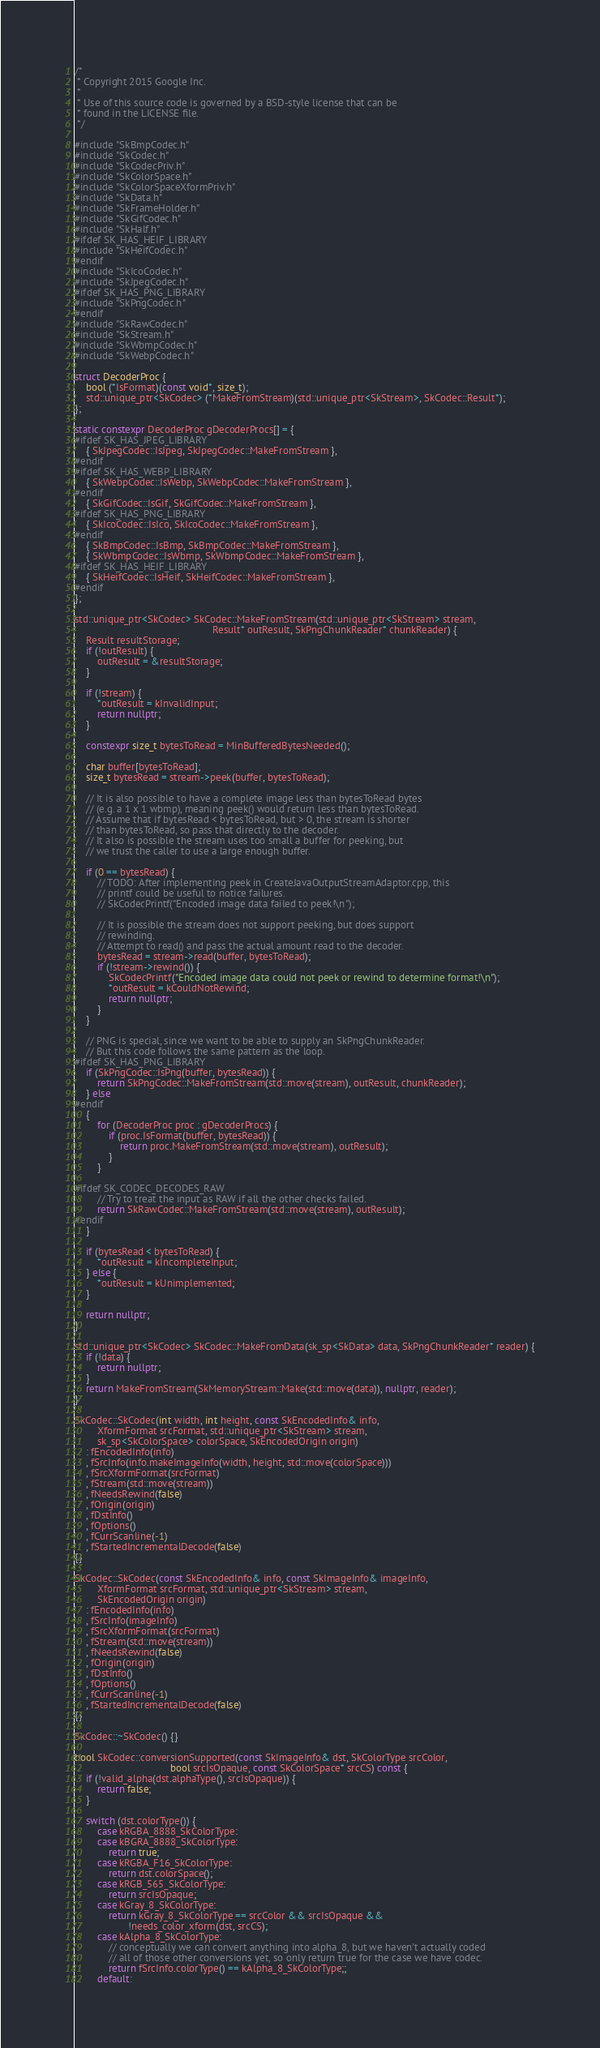Convert code to text. <code><loc_0><loc_0><loc_500><loc_500><_C++_>/*
 * Copyright 2015 Google Inc.
 *
 * Use of this source code is governed by a BSD-style license that can be
 * found in the LICENSE file.
 */

#include "SkBmpCodec.h"
#include "SkCodec.h"
#include "SkCodecPriv.h"
#include "SkColorSpace.h"
#include "SkColorSpaceXformPriv.h"
#include "SkData.h"
#include "SkFrameHolder.h"
#include "SkGifCodec.h"
#include "SkHalf.h"
#ifdef SK_HAS_HEIF_LIBRARY
#include "SkHeifCodec.h"
#endif
#include "SkIcoCodec.h"
#include "SkJpegCodec.h"
#ifdef SK_HAS_PNG_LIBRARY
#include "SkPngCodec.h"
#endif
#include "SkRawCodec.h"
#include "SkStream.h"
#include "SkWbmpCodec.h"
#include "SkWebpCodec.h"

struct DecoderProc {
    bool (*IsFormat)(const void*, size_t);
    std::unique_ptr<SkCodec> (*MakeFromStream)(std::unique_ptr<SkStream>, SkCodec::Result*);
};

static constexpr DecoderProc gDecoderProcs[] = {
#ifdef SK_HAS_JPEG_LIBRARY
    { SkJpegCodec::IsJpeg, SkJpegCodec::MakeFromStream },
#endif
#ifdef SK_HAS_WEBP_LIBRARY
    { SkWebpCodec::IsWebp, SkWebpCodec::MakeFromStream },
#endif
    { SkGifCodec::IsGif, SkGifCodec::MakeFromStream },
#ifdef SK_HAS_PNG_LIBRARY
    { SkIcoCodec::IsIco, SkIcoCodec::MakeFromStream },
#endif
    { SkBmpCodec::IsBmp, SkBmpCodec::MakeFromStream },
    { SkWbmpCodec::IsWbmp, SkWbmpCodec::MakeFromStream },
#ifdef SK_HAS_HEIF_LIBRARY
    { SkHeifCodec::IsHeif, SkHeifCodec::MakeFromStream },
#endif
};

std::unique_ptr<SkCodec> SkCodec::MakeFromStream(std::unique_ptr<SkStream> stream,
                                                 Result* outResult, SkPngChunkReader* chunkReader) {
    Result resultStorage;
    if (!outResult) {
        outResult = &resultStorage;
    }

    if (!stream) {
        *outResult = kInvalidInput;
        return nullptr;
    }

    constexpr size_t bytesToRead = MinBufferedBytesNeeded();

    char buffer[bytesToRead];
    size_t bytesRead = stream->peek(buffer, bytesToRead);

    // It is also possible to have a complete image less than bytesToRead bytes
    // (e.g. a 1 x 1 wbmp), meaning peek() would return less than bytesToRead.
    // Assume that if bytesRead < bytesToRead, but > 0, the stream is shorter
    // than bytesToRead, so pass that directly to the decoder.
    // It also is possible the stream uses too small a buffer for peeking, but
    // we trust the caller to use a large enough buffer.

    if (0 == bytesRead) {
        // TODO: After implementing peek in CreateJavaOutputStreamAdaptor.cpp, this
        // printf could be useful to notice failures.
        // SkCodecPrintf("Encoded image data failed to peek!\n");

        // It is possible the stream does not support peeking, but does support
        // rewinding.
        // Attempt to read() and pass the actual amount read to the decoder.
        bytesRead = stream->read(buffer, bytesToRead);
        if (!stream->rewind()) {
            SkCodecPrintf("Encoded image data could not peek or rewind to determine format!\n");
            *outResult = kCouldNotRewind;
            return nullptr;
        }
    }

    // PNG is special, since we want to be able to supply an SkPngChunkReader.
    // But this code follows the same pattern as the loop.
#ifdef SK_HAS_PNG_LIBRARY
    if (SkPngCodec::IsPng(buffer, bytesRead)) {
        return SkPngCodec::MakeFromStream(std::move(stream), outResult, chunkReader);
    } else
#endif
    {
        for (DecoderProc proc : gDecoderProcs) {
            if (proc.IsFormat(buffer, bytesRead)) {
                return proc.MakeFromStream(std::move(stream), outResult);
            }
        }

#ifdef SK_CODEC_DECODES_RAW
        // Try to treat the input as RAW if all the other checks failed.
        return SkRawCodec::MakeFromStream(std::move(stream), outResult);
#endif
    }

    if (bytesRead < bytesToRead) {
        *outResult = kIncompleteInput;
    } else {
        *outResult = kUnimplemented;
    }

    return nullptr;
}

std::unique_ptr<SkCodec> SkCodec::MakeFromData(sk_sp<SkData> data, SkPngChunkReader* reader) {
    if (!data) {
        return nullptr;
    }
    return MakeFromStream(SkMemoryStream::Make(std::move(data)), nullptr, reader);
}

SkCodec::SkCodec(int width, int height, const SkEncodedInfo& info,
        XformFormat srcFormat, std::unique_ptr<SkStream> stream,
        sk_sp<SkColorSpace> colorSpace, SkEncodedOrigin origin)
    : fEncodedInfo(info)
    , fSrcInfo(info.makeImageInfo(width, height, std::move(colorSpace)))
    , fSrcXformFormat(srcFormat)
    , fStream(std::move(stream))
    , fNeedsRewind(false)
    , fOrigin(origin)
    , fDstInfo()
    , fOptions()
    , fCurrScanline(-1)
    , fStartedIncrementalDecode(false)
{}

SkCodec::SkCodec(const SkEncodedInfo& info, const SkImageInfo& imageInfo,
        XformFormat srcFormat, std::unique_ptr<SkStream> stream,
        SkEncodedOrigin origin)
    : fEncodedInfo(info)
    , fSrcInfo(imageInfo)
    , fSrcXformFormat(srcFormat)
    , fStream(std::move(stream))
    , fNeedsRewind(false)
    , fOrigin(origin)
    , fDstInfo()
    , fOptions()
    , fCurrScanline(-1)
    , fStartedIncrementalDecode(false)
{}

SkCodec::~SkCodec() {}

bool SkCodec::conversionSupported(const SkImageInfo& dst, SkColorType srcColor,
                                  bool srcIsOpaque, const SkColorSpace* srcCS) const {
    if (!valid_alpha(dst.alphaType(), srcIsOpaque)) {
        return false;
    }

    switch (dst.colorType()) {
        case kRGBA_8888_SkColorType:
        case kBGRA_8888_SkColorType:
            return true;
        case kRGBA_F16_SkColorType:
            return dst.colorSpace();
        case kRGB_565_SkColorType:
            return srcIsOpaque;
        case kGray_8_SkColorType:
            return kGray_8_SkColorType == srcColor && srcIsOpaque &&
                   !needs_color_xform(dst, srcCS);
        case kAlpha_8_SkColorType:
            // conceptually we can convert anything into alpha_8, but we haven't actually coded
            // all of those other conversions yet, so only return true for the case we have codec.
            return fSrcInfo.colorType() == kAlpha_8_SkColorType;;
        default:</code> 